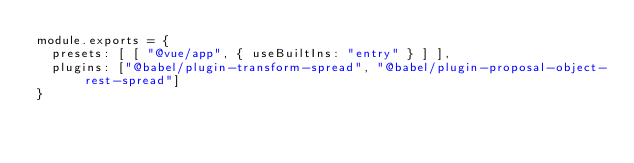Convert code to text. <code><loc_0><loc_0><loc_500><loc_500><_JavaScript_>module.exports = {
  presets: [ [ "@vue/app", { useBuiltIns: "entry" } ] ],
  plugins: ["@babel/plugin-transform-spread", "@babel/plugin-proposal-object-rest-spread"]
}
</code> 